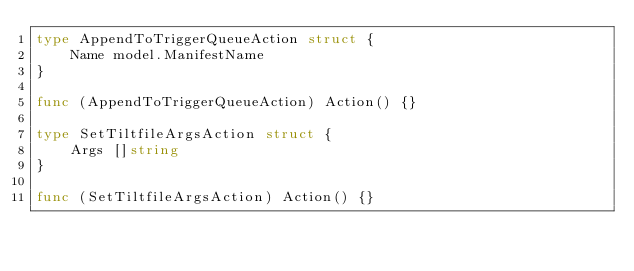Convert code to text. <code><loc_0><loc_0><loc_500><loc_500><_Go_>type AppendToTriggerQueueAction struct {
	Name model.ManifestName
}

func (AppendToTriggerQueueAction) Action() {}

type SetTiltfileArgsAction struct {
	Args []string
}

func (SetTiltfileArgsAction) Action() {}
</code> 